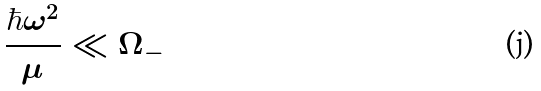Convert formula to latex. <formula><loc_0><loc_0><loc_500><loc_500>\frac { \hbar { \omega } ^ { 2 } } { \mu } \ll \Omega _ { - }</formula> 